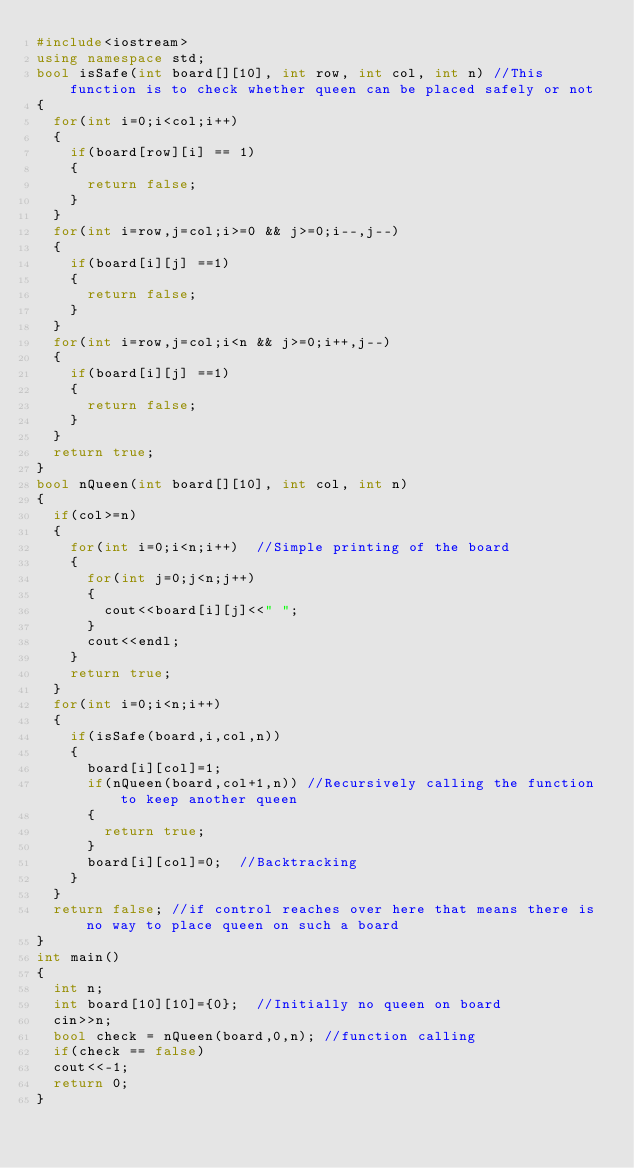Convert code to text. <code><loc_0><loc_0><loc_500><loc_500><_C++_>#include<iostream>
using namespace std;
bool isSafe(int board[][10], int row, int col, int n)	//This function is to check whether queen can be placed safely or not
{
	for(int i=0;i<col;i++)
	{
		if(board[row][i] == 1)
		{
			return false;
		}
	}
	for(int i=row,j=col;i>=0 && j>=0;i--,j--)
	{
		if(board[i][j] ==1)
		{
			return false;
		}
	}
	for(int i=row,j=col;i<n && j>=0;i++,j--)
	{
		if(board[i][j] ==1)
		{
			return false;
		}
	}
	return true;
}
bool nQueen(int board[][10], int col, int n)
{
	if(col>=n)
	{
		for(int i=0;i<n;i++)	//Simple printing of the board 
		{
			for(int j=0;j<n;j++)
			{
				cout<<board[i][j]<<" ";
			}
			cout<<endl;
		}
		return true;
	}
	for(int i=0;i<n;i++)
	{
		if(isSafe(board,i,col,n))
		{
			board[i][col]=1;
			if(nQueen(board,col+1,n))	//Recursively calling the function to keep another queen
			{
				return true;
			}
			board[i][col]=0; 	//Backtracking
		}
	}
	return false;	//if control reaches over here that means there is no way to place queen on such a board
}
int main()
{
	int n;
	int board[10][10]={0};	//Initially no queen on board
	cin>>n;
	bool check = nQueen(board,0,n);	//function calling
	if(check == false)
	cout<<-1;
	return 0;
}
</code> 